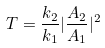<formula> <loc_0><loc_0><loc_500><loc_500>T = \frac { k _ { 2 } } { k _ { 1 } } | \frac { A _ { 2 } } { A _ { 1 } } | ^ { 2 }</formula> 